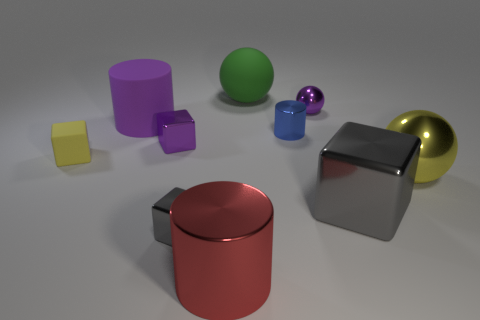What number of other objects are there of the same size as the purple cube?
Keep it short and to the point. 4. There is a metal ball that is the same color as the small matte thing; what size is it?
Offer a very short reply. Large. What is the yellow thing on the left side of the large gray cube behind the large red metal object made of?
Your answer should be very brief. Rubber. There is a large purple object; are there any big green rubber things in front of it?
Keep it short and to the point. No. Are there more big purple rubber cylinders that are behind the large red shiny cylinder than big cyan spheres?
Your answer should be very brief. Yes. Is there a large cylinder that has the same color as the tiny ball?
Give a very brief answer. Yes. What is the color of the metal block that is the same size as the rubber cylinder?
Give a very brief answer. Gray. There is a tiny purple metal object on the left side of the green sphere; are there any yellow metal spheres that are on the left side of it?
Make the answer very short. No. What material is the yellow object that is left of the large red cylinder?
Provide a succinct answer. Rubber. Does the small purple object to the left of the tiny purple sphere have the same material as the gray object that is on the left side of the tiny purple metallic ball?
Your answer should be very brief. Yes. 